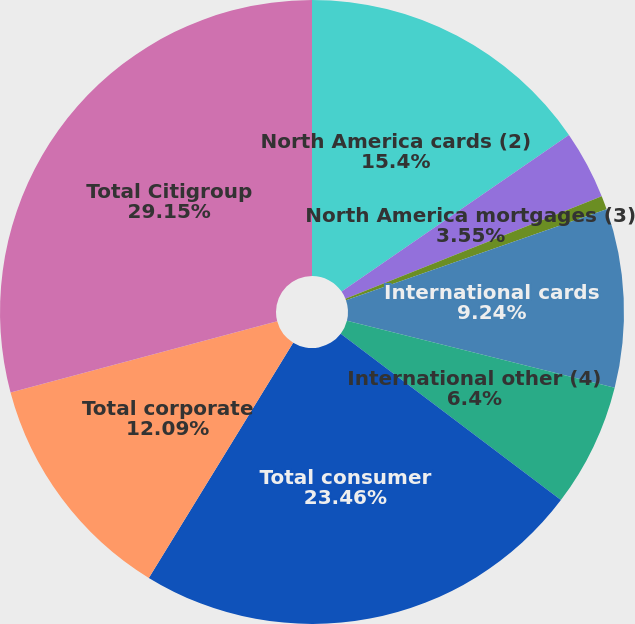<chart> <loc_0><loc_0><loc_500><loc_500><pie_chart><fcel>North America cards (2)<fcel>North America mortgages (3)<fcel>North America other<fcel>International cards<fcel>International other (4)<fcel>Total consumer<fcel>Total corporate<fcel>Total Citigroup<nl><fcel>15.4%<fcel>3.55%<fcel>0.71%<fcel>9.24%<fcel>6.4%<fcel>23.46%<fcel>12.09%<fcel>29.15%<nl></chart> 